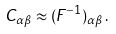Convert formula to latex. <formula><loc_0><loc_0><loc_500><loc_500>C _ { \alpha \beta } \approx ( { F } ^ { - 1 } ) _ { \alpha \beta } \, .</formula> 